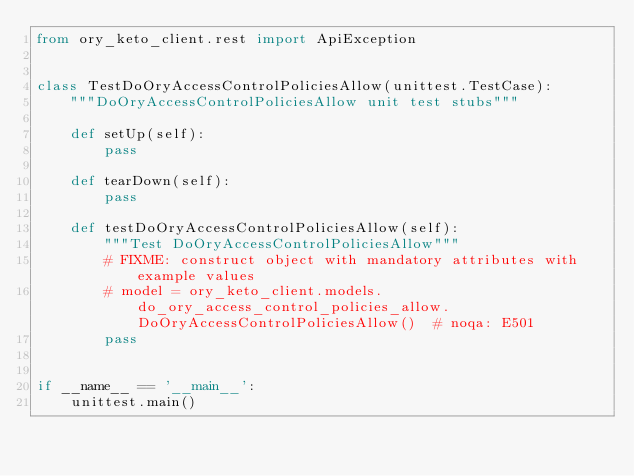Convert code to text. <code><loc_0><loc_0><loc_500><loc_500><_Python_>from ory_keto_client.rest import ApiException


class TestDoOryAccessControlPoliciesAllow(unittest.TestCase):
    """DoOryAccessControlPoliciesAllow unit test stubs"""

    def setUp(self):
        pass

    def tearDown(self):
        pass

    def testDoOryAccessControlPoliciesAllow(self):
        """Test DoOryAccessControlPoliciesAllow"""
        # FIXME: construct object with mandatory attributes with example values
        # model = ory_keto_client.models.do_ory_access_control_policies_allow.DoOryAccessControlPoliciesAllow()  # noqa: E501
        pass


if __name__ == '__main__':
    unittest.main()
</code> 